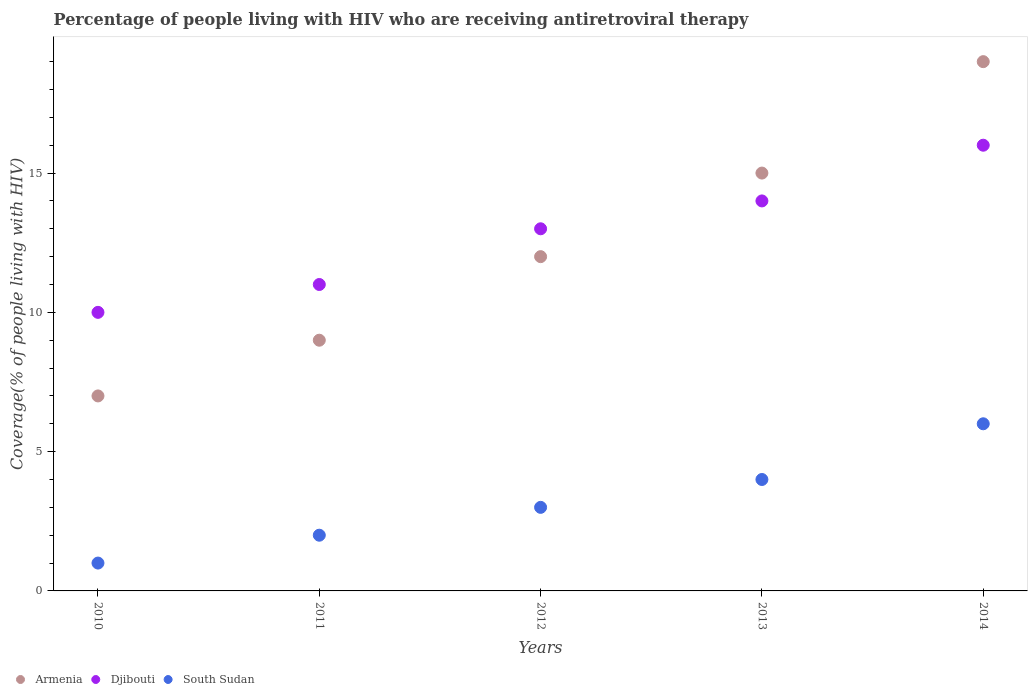How many different coloured dotlines are there?
Give a very brief answer. 3. Is the number of dotlines equal to the number of legend labels?
Provide a short and direct response. Yes. What is the percentage of the HIV infected people who are receiving antiretroviral therapy in Djibouti in 2010?
Give a very brief answer. 10. Across all years, what is the minimum percentage of the HIV infected people who are receiving antiretroviral therapy in Djibouti?
Keep it short and to the point. 10. In which year was the percentage of the HIV infected people who are receiving antiretroviral therapy in Djibouti maximum?
Your answer should be compact. 2014. What is the total percentage of the HIV infected people who are receiving antiretroviral therapy in Djibouti in the graph?
Your response must be concise. 64. What is the difference between the percentage of the HIV infected people who are receiving antiretroviral therapy in Armenia in 2010 and that in 2014?
Give a very brief answer. -12. What is the difference between the percentage of the HIV infected people who are receiving antiretroviral therapy in Armenia in 2013 and the percentage of the HIV infected people who are receiving antiretroviral therapy in South Sudan in 2010?
Your answer should be very brief. 14. What is the average percentage of the HIV infected people who are receiving antiretroviral therapy in Armenia per year?
Provide a succinct answer. 12.4. In the year 2012, what is the difference between the percentage of the HIV infected people who are receiving antiretroviral therapy in Djibouti and percentage of the HIV infected people who are receiving antiretroviral therapy in South Sudan?
Ensure brevity in your answer.  10. Is the percentage of the HIV infected people who are receiving antiretroviral therapy in Djibouti in 2011 less than that in 2013?
Offer a terse response. Yes. What is the difference between the highest and the lowest percentage of the HIV infected people who are receiving antiretroviral therapy in Armenia?
Offer a very short reply. 12. Is the sum of the percentage of the HIV infected people who are receiving antiretroviral therapy in Armenia in 2011 and 2014 greater than the maximum percentage of the HIV infected people who are receiving antiretroviral therapy in South Sudan across all years?
Provide a succinct answer. Yes. Is it the case that in every year, the sum of the percentage of the HIV infected people who are receiving antiretroviral therapy in Djibouti and percentage of the HIV infected people who are receiving antiretroviral therapy in South Sudan  is greater than the percentage of the HIV infected people who are receiving antiretroviral therapy in Armenia?
Provide a short and direct response. Yes. Does the percentage of the HIV infected people who are receiving antiretroviral therapy in Djibouti monotonically increase over the years?
Keep it short and to the point. Yes. Is the percentage of the HIV infected people who are receiving antiretroviral therapy in Djibouti strictly less than the percentage of the HIV infected people who are receiving antiretroviral therapy in Armenia over the years?
Provide a succinct answer. No. How many years are there in the graph?
Your answer should be compact. 5. Are the values on the major ticks of Y-axis written in scientific E-notation?
Your answer should be very brief. No. Where does the legend appear in the graph?
Keep it short and to the point. Bottom left. How many legend labels are there?
Provide a succinct answer. 3. What is the title of the graph?
Make the answer very short. Percentage of people living with HIV who are receiving antiretroviral therapy. What is the label or title of the Y-axis?
Your answer should be very brief. Coverage(% of people living with HIV). What is the Coverage(% of people living with HIV) of Armenia in 2010?
Provide a succinct answer. 7. What is the Coverage(% of people living with HIV) of Djibouti in 2010?
Keep it short and to the point. 10. What is the Coverage(% of people living with HIV) of Armenia in 2011?
Your response must be concise. 9. What is the Coverage(% of people living with HIV) of Djibouti in 2011?
Keep it short and to the point. 11. What is the Coverage(% of people living with HIV) of South Sudan in 2011?
Make the answer very short. 2. What is the Coverage(% of people living with HIV) of Armenia in 2012?
Give a very brief answer. 12. What is the Coverage(% of people living with HIV) of South Sudan in 2012?
Provide a short and direct response. 3. What is the Coverage(% of people living with HIV) in Djibouti in 2013?
Provide a succinct answer. 14. What is the Coverage(% of people living with HIV) in South Sudan in 2013?
Ensure brevity in your answer.  4. What is the Coverage(% of people living with HIV) in Armenia in 2014?
Provide a succinct answer. 19. What is the Coverage(% of people living with HIV) in South Sudan in 2014?
Give a very brief answer. 6. Across all years, what is the maximum Coverage(% of people living with HIV) of Djibouti?
Offer a terse response. 16. Across all years, what is the minimum Coverage(% of people living with HIV) in Armenia?
Provide a succinct answer. 7. What is the total Coverage(% of people living with HIV) in South Sudan in the graph?
Give a very brief answer. 16. What is the difference between the Coverage(% of people living with HIV) of Armenia in 2010 and that in 2012?
Give a very brief answer. -5. What is the difference between the Coverage(% of people living with HIV) of Djibouti in 2010 and that in 2012?
Your answer should be very brief. -3. What is the difference between the Coverage(% of people living with HIV) of South Sudan in 2010 and that in 2013?
Ensure brevity in your answer.  -3. What is the difference between the Coverage(% of people living with HIV) of Djibouti in 2010 and that in 2014?
Give a very brief answer. -6. What is the difference between the Coverage(% of people living with HIV) in Djibouti in 2011 and that in 2012?
Provide a short and direct response. -2. What is the difference between the Coverage(% of people living with HIV) in South Sudan in 2011 and that in 2012?
Your response must be concise. -1. What is the difference between the Coverage(% of people living with HIV) of Armenia in 2012 and that in 2014?
Give a very brief answer. -7. What is the difference between the Coverage(% of people living with HIV) in South Sudan in 2012 and that in 2014?
Offer a very short reply. -3. What is the difference between the Coverage(% of people living with HIV) in Djibouti in 2013 and that in 2014?
Your answer should be very brief. -2. What is the difference between the Coverage(% of people living with HIV) in South Sudan in 2013 and that in 2014?
Ensure brevity in your answer.  -2. What is the difference between the Coverage(% of people living with HIV) of Armenia in 2010 and the Coverage(% of people living with HIV) of Djibouti in 2011?
Your answer should be very brief. -4. What is the difference between the Coverage(% of people living with HIV) in Djibouti in 2010 and the Coverage(% of people living with HIV) in South Sudan in 2011?
Your answer should be very brief. 8. What is the difference between the Coverage(% of people living with HIV) in Armenia in 2010 and the Coverage(% of people living with HIV) in Djibouti in 2012?
Offer a terse response. -6. What is the difference between the Coverage(% of people living with HIV) of Djibouti in 2010 and the Coverage(% of people living with HIV) of South Sudan in 2012?
Offer a very short reply. 7. What is the difference between the Coverage(% of people living with HIV) in Armenia in 2010 and the Coverage(% of people living with HIV) in Djibouti in 2013?
Offer a very short reply. -7. What is the difference between the Coverage(% of people living with HIV) in Armenia in 2010 and the Coverage(% of people living with HIV) in South Sudan in 2013?
Your answer should be compact. 3. What is the difference between the Coverage(% of people living with HIV) in Djibouti in 2010 and the Coverage(% of people living with HIV) in South Sudan in 2013?
Offer a very short reply. 6. What is the difference between the Coverage(% of people living with HIV) in Armenia in 2011 and the Coverage(% of people living with HIV) in Djibouti in 2012?
Your answer should be compact. -4. What is the difference between the Coverage(% of people living with HIV) in Armenia in 2011 and the Coverage(% of people living with HIV) in South Sudan in 2012?
Ensure brevity in your answer.  6. What is the difference between the Coverage(% of people living with HIV) of Djibouti in 2011 and the Coverage(% of people living with HIV) of South Sudan in 2012?
Keep it short and to the point. 8. What is the difference between the Coverage(% of people living with HIV) in Armenia in 2011 and the Coverage(% of people living with HIV) in South Sudan in 2013?
Ensure brevity in your answer.  5. What is the difference between the Coverage(% of people living with HIV) of Armenia in 2011 and the Coverage(% of people living with HIV) of Djibouti in 2014?
Your answer should be compact. -7. What is the difference between the Coverage(% of people living with HIV) of Armenia in 2011 and the Coverage(% of people living with HIV) of South Sudan in 2014?
Your answer should be compact. 3. What is the difference between the Coverage(% of people living with HIV) of Djibouti in 2011 and the Coverage(% of people living with HIV) of South Sudan in 2014?
Make the answer very short. 5. What is the difference between the Coverage(% of people living with HIV) of Armenia in 2012 and the Coverage(% of people living with HIV) of Djibouti in 2013?
Provide a short and direct response. -2. What is the difference between the Coverage(% of people living with HIV) of Armenia in 2012 and the Coverage(% of people living with HIV) of South Sudan in 2014?
Your answer should be compact. 6. What is the difference between the Coverage(% of people living with HIV) of Djibouti in 2012 and the Coverage(% of people living with HIV) of South Sudan in 2014?
Make the answer very short. 7. What is the difference between the Coverage(% of people living with HIV) in Armenia in 2013 and the Coverage(% of people living with HIV) in South Sudan in 2014?
Provide a succinct answer. 9. What is the difference between the Coverage(% of people living with HIV) in Djibouti in 2013 and the Coverage(% of people living with HIV) in South Sudan in 2014?
Offer a very short reply. 8. What is the average Coverage(% of people living with HIV) of South Sudan per year?
Keep it short and to the point. 3.2. In the year 2010, what is the difference between the Coverage(% of people living with HIV) of Armenia and Coverage(% of people living with HIV) of South Sudan?
Your response must be concise. 6. In the year 2010, what is the difference between the Coverage(% of people living with HIV) of Djibouti and Coverage(% of people living with HIV) of South Sudan?
Give a very brief answer. 9. In the year 2011, what is the difference between the Coverage(% of people living with HIV) in Armenia and Coverage(% of people living with HIV) in Djibouti?
Provide a short and direct response. -2. In the year 2012, what is the difference between the Coverage(% of people living with HIV) in Armenia and Coverage(% of people living with HIV) in Djibouti?
Your answer should be compact. -1. In the year 2013, what is the difference between the Coverage(% of people living with HIV) of Armenia and Coverage(% of people living with HIV) of Djibouti?
Give a very brief answer. 1. In the year 2014, what is the difference between the Coverage(% of people living with HIV) of Armenia and Coverage(% of people living with HIV) of Djibouti?
Your answer should be compact. 3. In the year 2014, what is the difference between the Coverage(% of people living with HIV) of Armenia and Coverage(% of people living with HIV) of South Sudan?
Ensure brevity in your answer.  13. What is the ratio of the Coverage(% of people living with HIV) in Armenia in 2010 to that in 2011?
Your response must be concise. 0.78. What is the ratio of the Coverage(% of people living with HIV) in Djibouti in 2010 to that in 2011?
Give a very brief answer. 0.91. What is the ratio of the Coverage(% of people living with HIV) of South Sudan in 2010 to that in 2011?
Ensure brevity in your answer.  0.5. What is the ratio of the Coverage(% of people living with HIV) in Armenia in 2010 to that in 2012?
Make the answer very short. 0.58. What is the ratio of the Coverage(% of people living with HIV) of Djibouti in 2010 to that in 2012?
Give a very brief answer. 0.77. What is the ratio of the Coverage(% of people living with HIV) of Armenia in 2010 to that in 2013?
Offer a terse response. 0.47. What is the ratio of the Coverage(% of people living with HIV) of South Sudan in 2010 to that in 2013?
Your answer should be compact. 0.25. What is the ratio of the Coverage(% of people living with HIV) of Armenia in 2010 to that in 2014?
Your response must be concise. 0.37. What is the ratio of the Coverage(% of people living with HIV) of Djibouti in 2010 to that in 2014?
Your response must be concise. 0.62. What is the ratio of the Coverage(% of people living with HIV) of Djibouti in 2011 to that in 2012?
Provide a succinct answer. 0.85. What is the ratio of the Coverage(% of people living with HIV) of Djibouti in 2011 to that in 2013?
Ensure brevity in your answer.  0.79. What is the ratio of the Coverage(% of people living with HIV) in South Sudan in 2011 to that in 2013?
Offer a terse response. 0.5. What is the ratio of the Coverage(% of people living with HIV) in Armenia in 2011 to that in 2014?
Offer a terse response. 0.47. What is the ratio of the Coverage(% of people living with HIV) of Djibouti in 2011 to that in 2014?
Provide a short and direct response. 0.69. What is the ratio of the Coverage(% of people living with HIV) of Armenia in 2012 to that in 2013?
Provide a short and direct response. 0.8. What is the ratio of the Coverage(% of people living with HIV) in Djibouti in 2012 to that in 2013?
Your answer should be compact. 0.93. What is the ratio of the Coverage(% of people living with HIV) of Armenia in 2012 to that in 2014?
Your answer should be compact. 0.63. What is the ratio of the Coverage(% of people living with HIV) of Djibouti in 2012 to that in 2014?
Offer a very short reply. 0.81. What is the ratio of the Coverage(% of people living with HIV) in Armenia in 2013 to that in 2014?
Ensure brevity in your answer.  0.79. What is the ratio of the Coverage(% of people living with HIV) of South Sudan in 2013 to that in 2014?
Your response must be concise. 0.67. What is the difference between the highest and the lowest Coverage(% of people living with HIV) in Armenia?
Provide a succinct answer. 12. What is the difference between the highest and the lowest Coverage(% of people living with HIV) of South Sudan?
Keep it short and to the point. 5. 